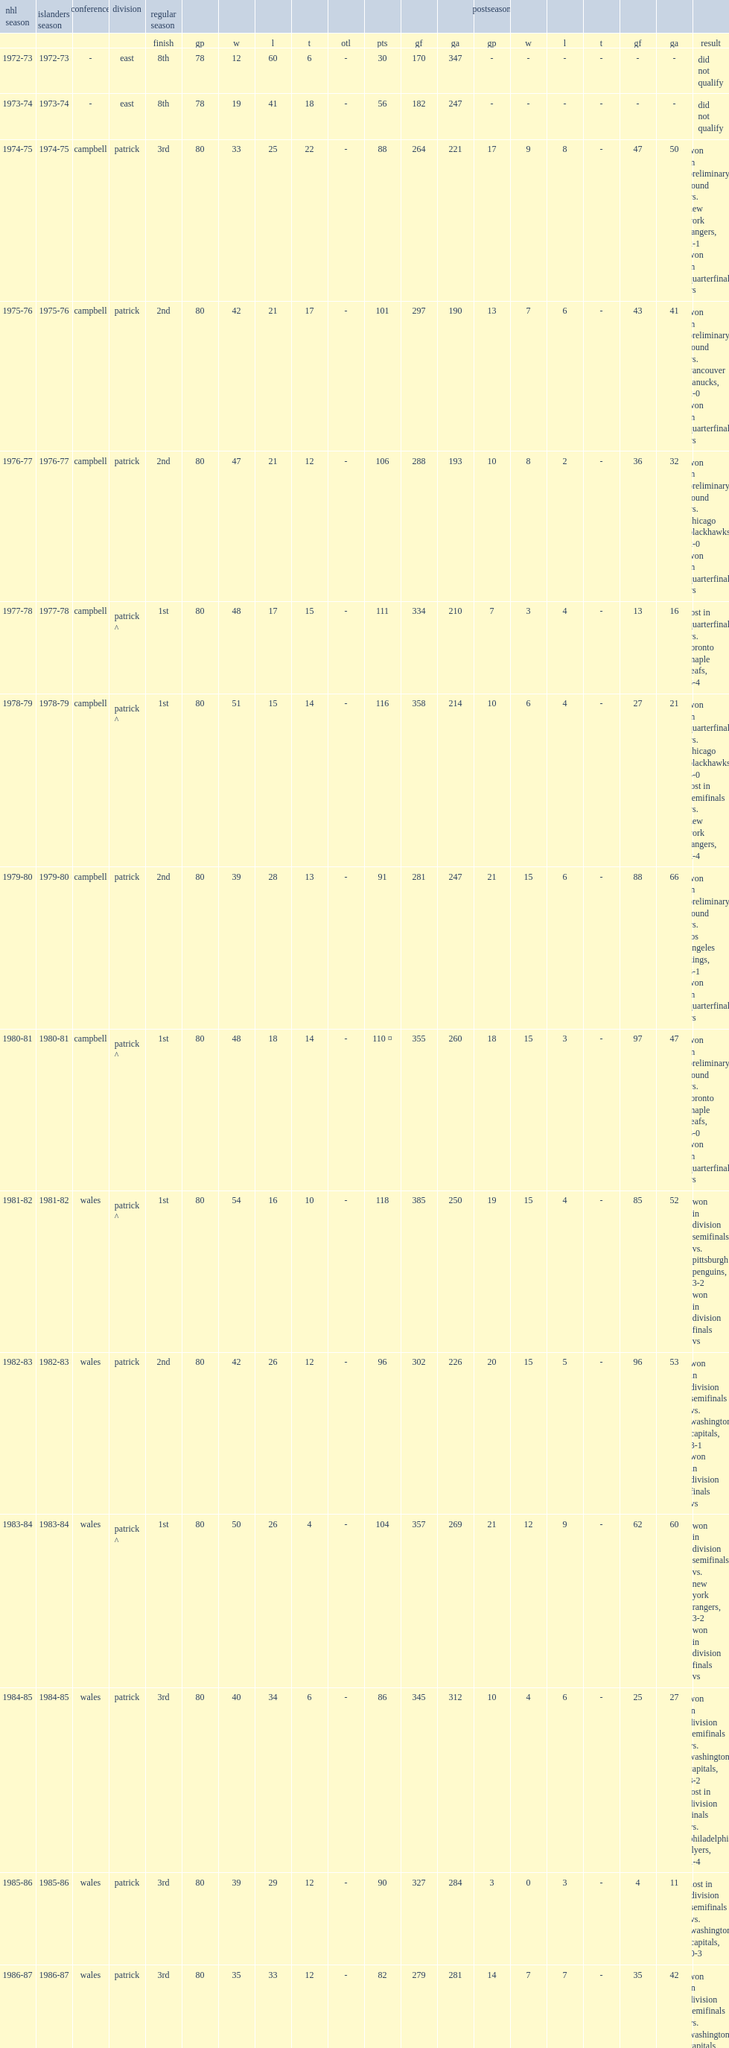Which new york islanders season was the 37th season in the franchise's history? 2008-09. 